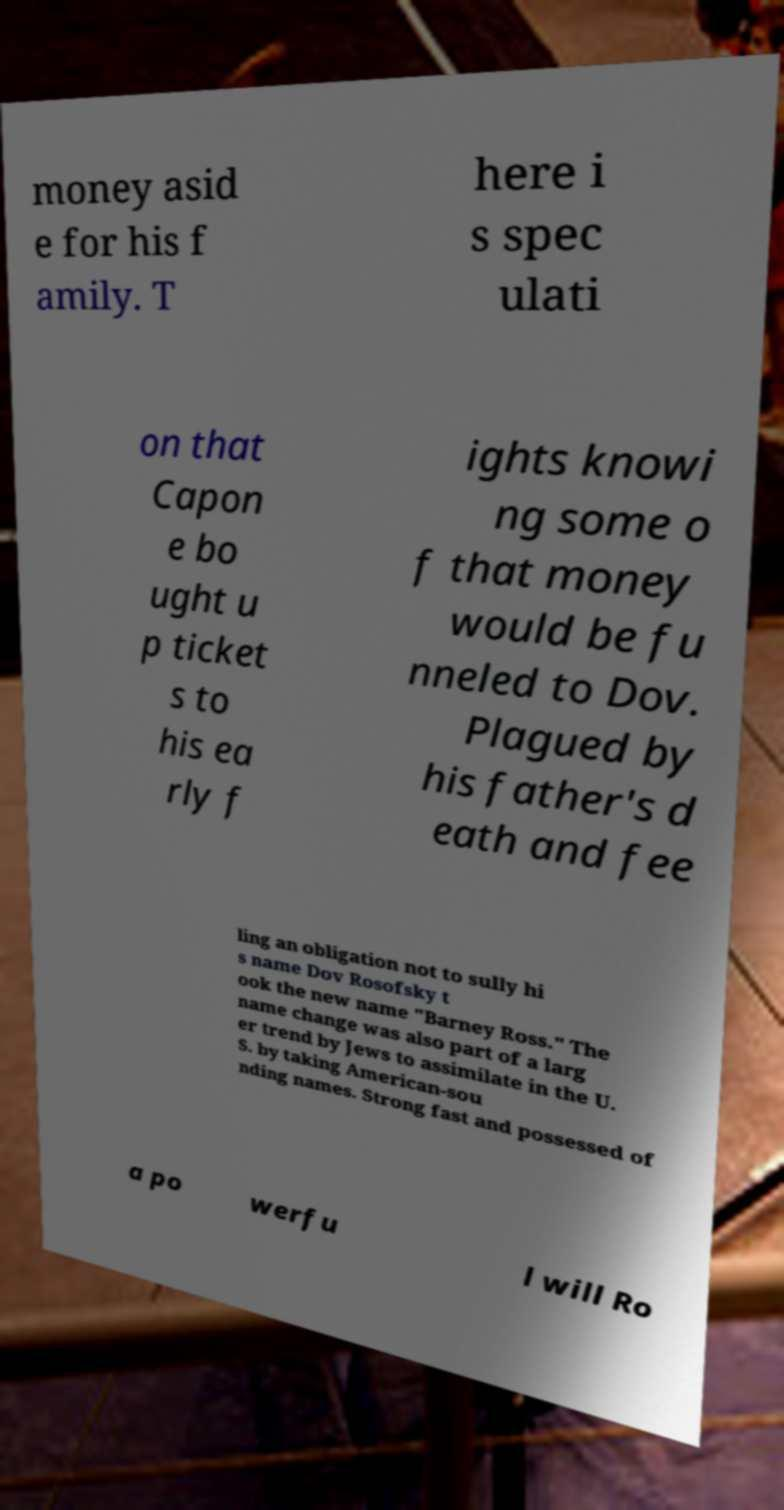Can you read and provide the text displayed in the image?This photo seems to have some interesting text. Can you extract and type it out for me? money asid e for his f amily. T here i s spec ulati on that Capon e bo ught u p ticket s to his ea rly f ights knowi ng some o f that money would be fu nneled to Dov. Plagued by his father's d eath and fee ling an obligation not to sully hi s name Dov Rosofsky t ook the new name "Barney Ross." The name change was also part of a larg er trend by Jews to assimilate in the U. S. by taking American-sou nding names. Strong fast and possessed of a po werfu l will Ro 